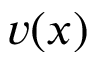Convert formula to latex. <formula><loc_0><loc_0><loc_500><loc_500>v ( x )</formula> 